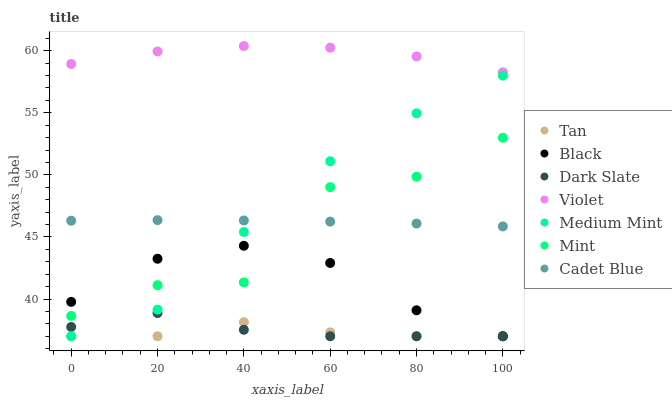Does Tan have the minimum area under the curve?
Answer yes or no. Yes. Does Violet have the maximum area under the curve?
Answer yes or no. Yes. Does Cadet Blue have the minimum area under the curve?
Answer yes or no. No. Does Cadet Blue have the maximum area under the curve?
Answer yes or no. No. Is Cadet Blue the smoothest?
Answer yes or no. Yes. Is Mint the roughest?
Answer yes or no. Yes. Is Dark Slate the smoothest?
Answer yes or no. No. Is Dark Slate the roughest?
Answer yes or no. No. Does Medium Mint have the lowest value?
Answer yes or no. Yes. Does Cadet Blue have the lowest value?
Answer yes or no. No. Does Violet have the highest value?
Answer yes or no. Yes. Does Cadet Blue have the highest value?
Answer yes or no. No. Is Black less than Cadet Blue?
Answer yes or no. Yes. Is Cadet Blue greater than Tan?
Answer yes or no. Yes. Does Dark Slate intersect Medium Mint?
Answer yes or no. Yes. Is Dark Slate less than Medium Mint?
Answer yes or no. No. Is Dark Slate greater than Medium Mint?
Answer yes or no. No. Does Black intersect Cadet Blue?
Answer yes or no. No. 